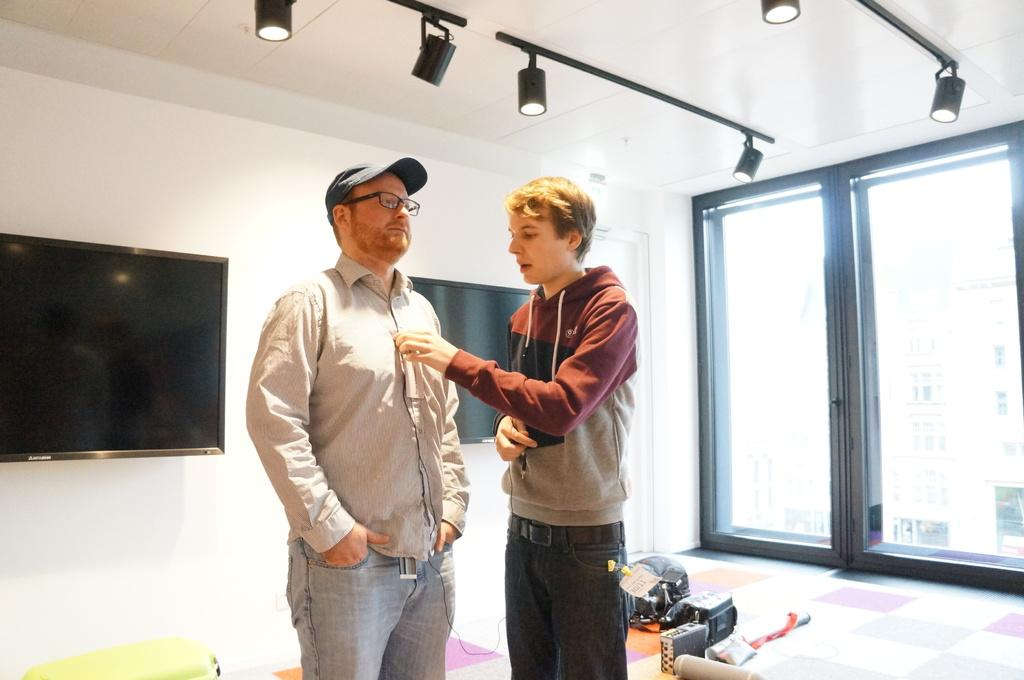How many people are in the middle of the image? There are two men in the middle of the image. What can be seen in the background of the image? There are televisions in the background of the image. What is visible at the top of the image? There are lights visible at the top of the image. What type of architectural feature might be present on the right side of the image? There may be glass doors on the right side of the image. Where is the chicken in the field in the image? There is no chicken or field present in the image. Who is the aunt in the image? There is no mention of an aunt in the image. 